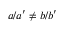Convert formula to latex. <formula><loc_0><loc_0><loc_500><loc_500>a / a ^ { \prime } \ne b / b ^ { \prime }</formula> 